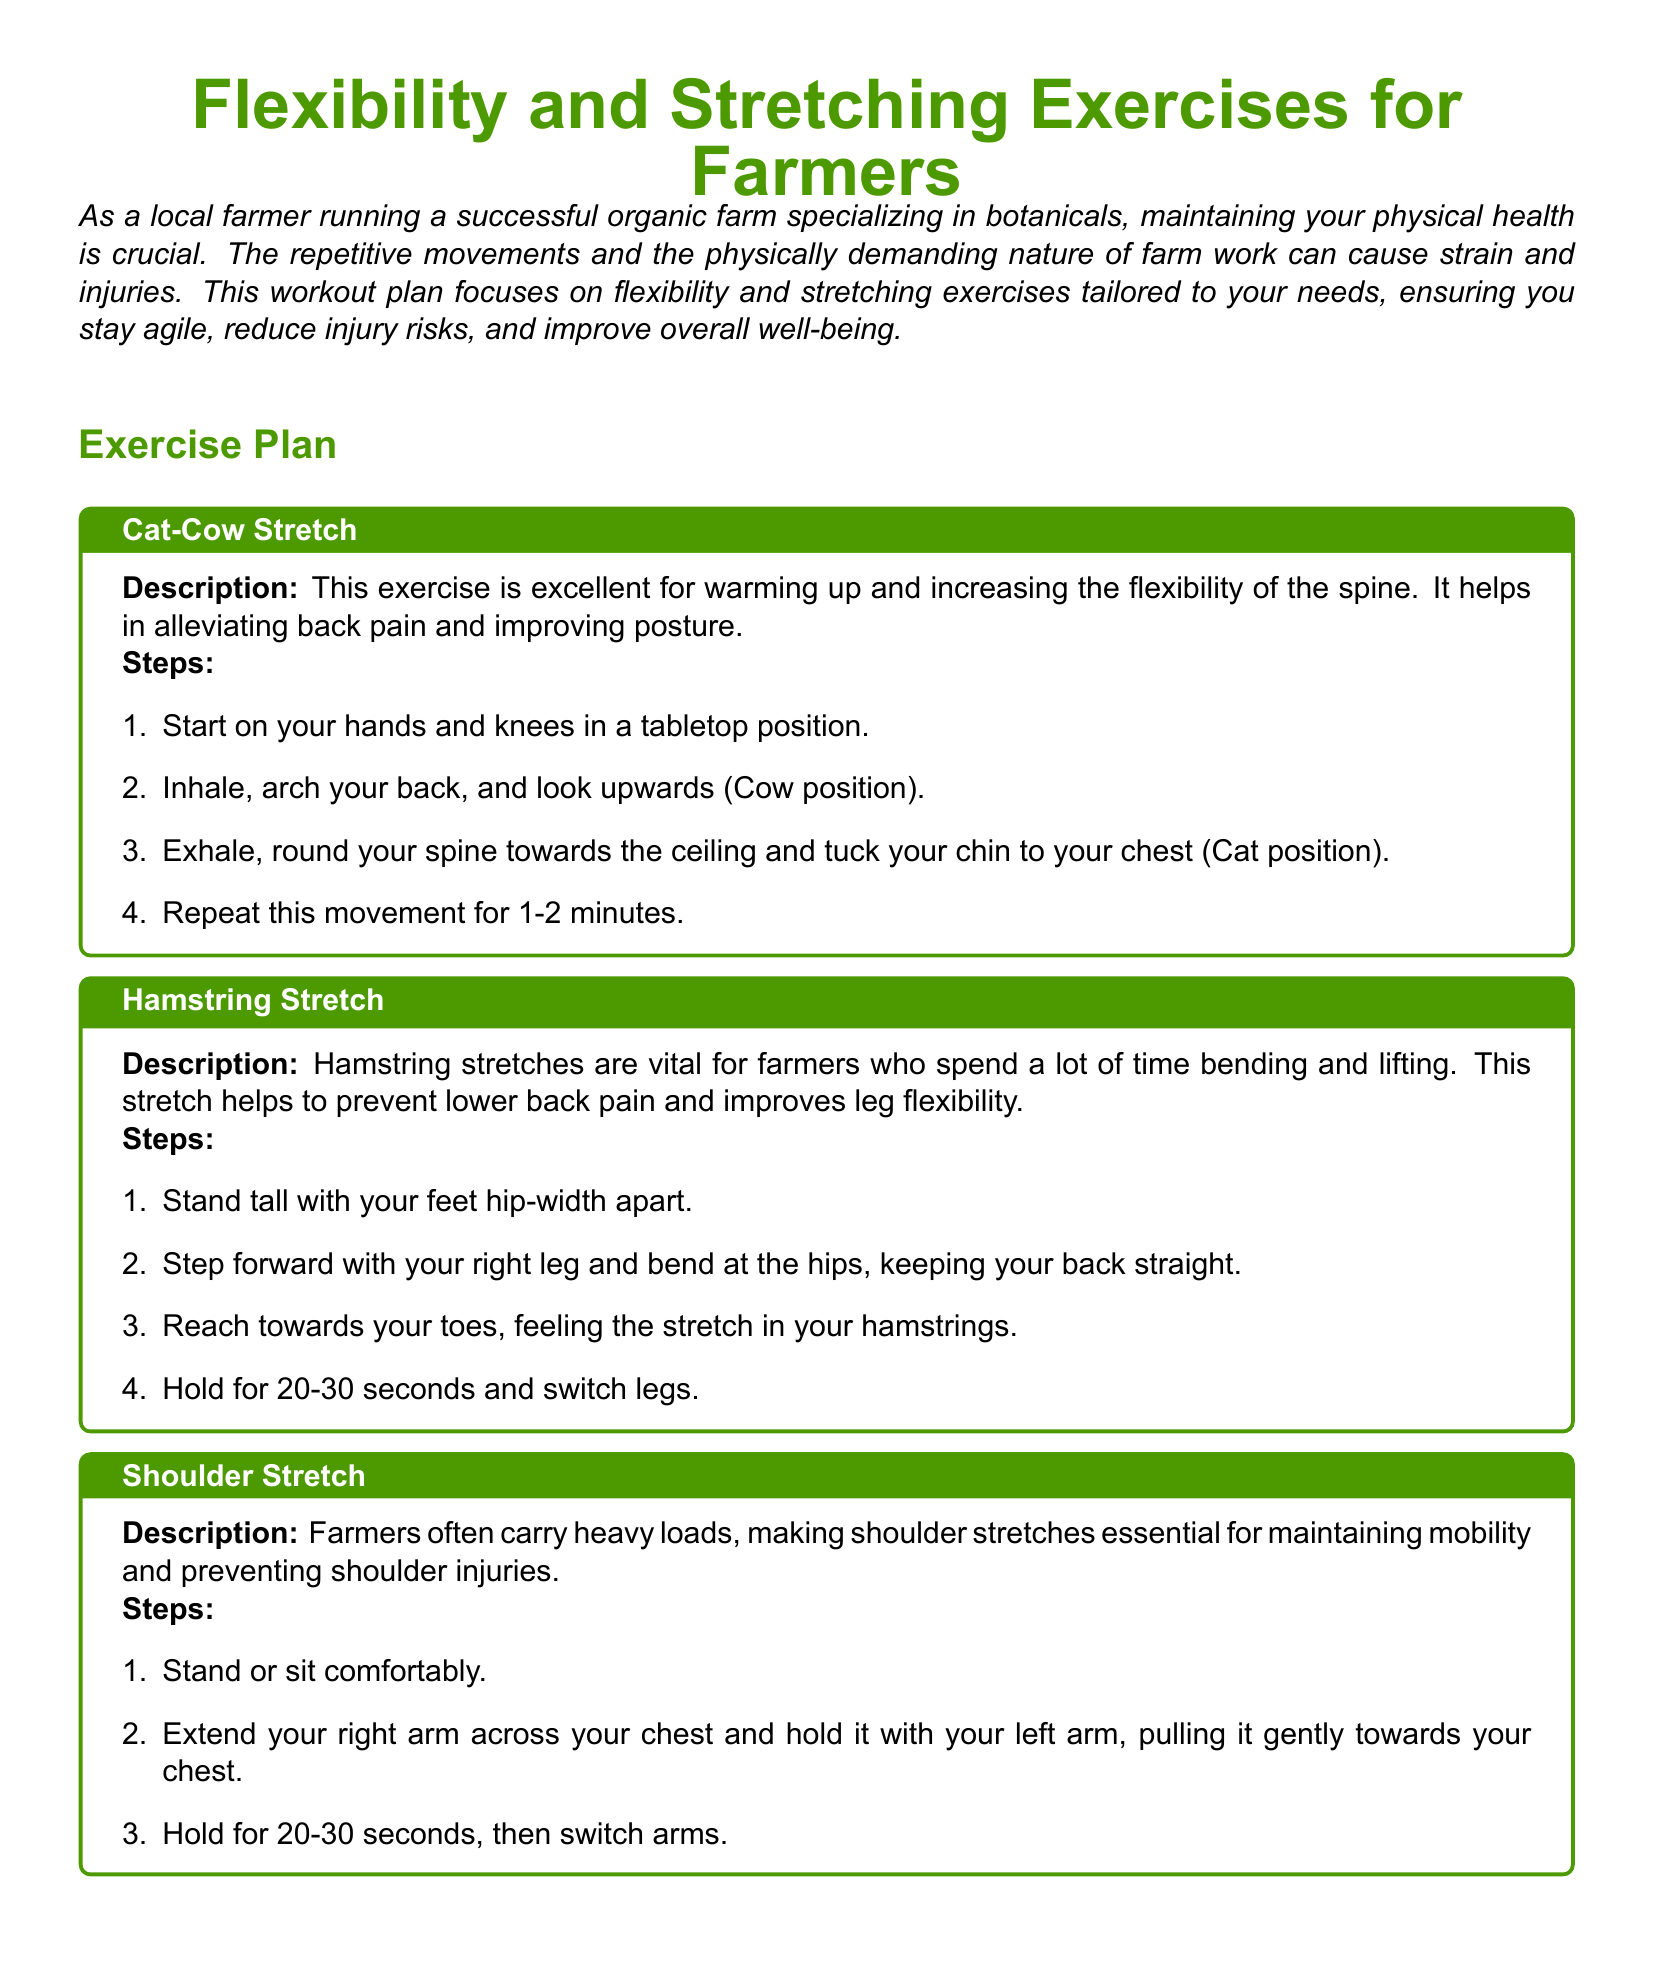What is the title of the document? The title of the document is prominently displayed at the top, which is "Flexibility and Stretching Exercises for Farmers."
Answer: Flexibility and Stretching Exercises for Farmers What type of exercises does the document focus on? The document is centered around exercises that improve physical health, specifically flexibility and stretching.
Answer: Flexibility and stretching How many stretching exercises are listed in the document? The document contains a section that details six specific stretching exercises for farmers.
Answer: Six What is the first exercise mentioned in the document? The first exercise in the list is detailed in the first exercise block titled "Cat-Cow Stretch."
Answer: Cat-Cow Stretch For how long should you hold the Hamstring Stretch? The document states that the Hamstring Stretch should be held for 20-30 seconds.
Answer: 20-30 seconds What is one benefit of the Shoulder Stretch mentioned? The Shoulder Stretch is described as essential for maintaining mobility and preventing shoulder injuries.
Answer: Preventing shoulder injuries Which exercise helps in preventing carpal tunnel syndrome? The exercise that focuses on preventing carpal tunnel syndrome is the "Wrist and Forearm Stretch."
Answer: Wrist and Forearm Stretch What is the description of the Quadriceps Stretch? The description of the Quadriceps Stretch involves alleviating tension from prolonged standing and walking, common in farming activities.
Answer: Alleviating tension from prolonged standing and walking What is the recommendation for performing the exercises? The document recommends performing each exercise slowly and steadily, avoiding any sudden movements.
Answer: Slowly and steadily 